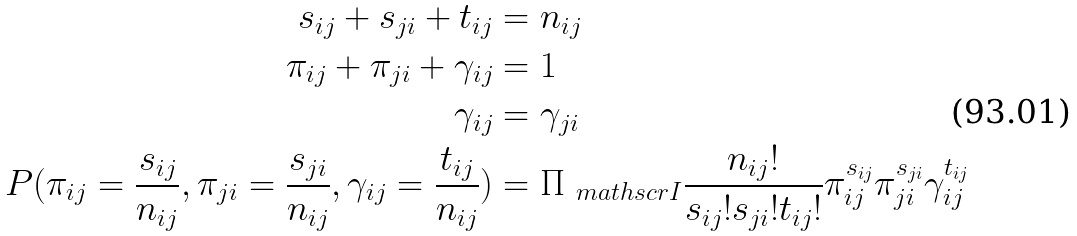Convert formula to latex. <formula><loc_0><loc_0><loc_500><loc_500>s _ { i j } + s _ { j i } + t _ { i j } & = n _ { i j } \\ \pi _ { i j } + \pi _ { j i } + \gamma _ { i j } & = 1 \\ \gamma _ { i j } & = \gamma _ { j i } \\ P ( \pi _ { i j } = \frac { s _ { i j } } { n _ { i j } } , \pi _ { j i } = \frac { s _ { j i } } { n _ { i j } } , \gamma _ { i j } = \frac { t _ { i j } } { n _ { i j } } ) & = \Pi _ { \ m a t h s c r { I } } \frac { n _ { i j } ! } { s _ { i j } ! s _ { j i } ! t _ { i j } ! } \pi _ { i j } ^ { s _ { i j } } \pi _ { j i } ^ { s _ { j i } } \gamma _ { i j } ^ { t _ { i j } }</formula> 